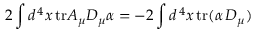Convert formula to latex. <formula><loc_0><loc_0><loc_500><loc_500>2 \int d ^ { \, 4 } x \, t r A _ { \mu } D _ { \mu } \alpha = - 2 \int d ^ { \, 4 } x \, t r ( \alpha \, D _ { \mu } )</formula> 